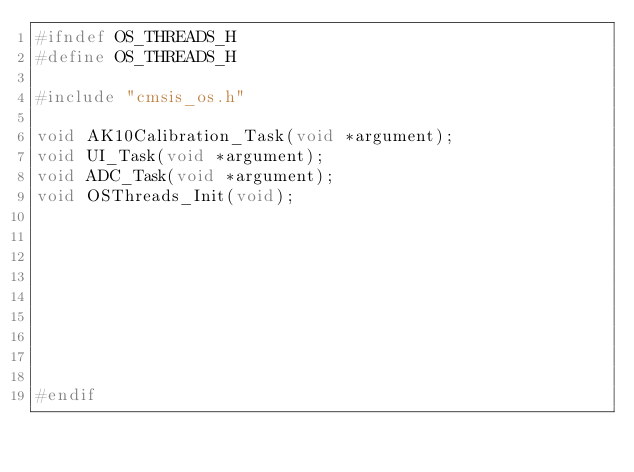<code> <loc_0><loc_0><loc_500><loc_500><_C_>#ifndef OS_THREADS_H
#define OS_THREADS_H

#include "cmsis_os.h"

void AK10Calibration_Task(void *argument);
void UI_Task(void *argument);
void ADC_Task(void *argument);
void OSThreads_Init(void);









#endif
</code> 